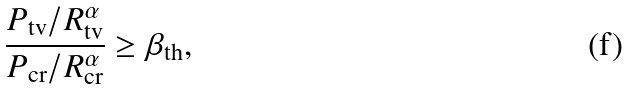Convert formula to latex. <formula><loc_0><loc_0><loc_500><loc_500>\frac { P _ { \text {tv} } / R _ { \text {tv} } ^ { \alpha } } { P _ { \text {cr} } / R _ { \text {cr} } ^ { \alpha } } \geq \beta _ { \text {th} } ,</formula> 